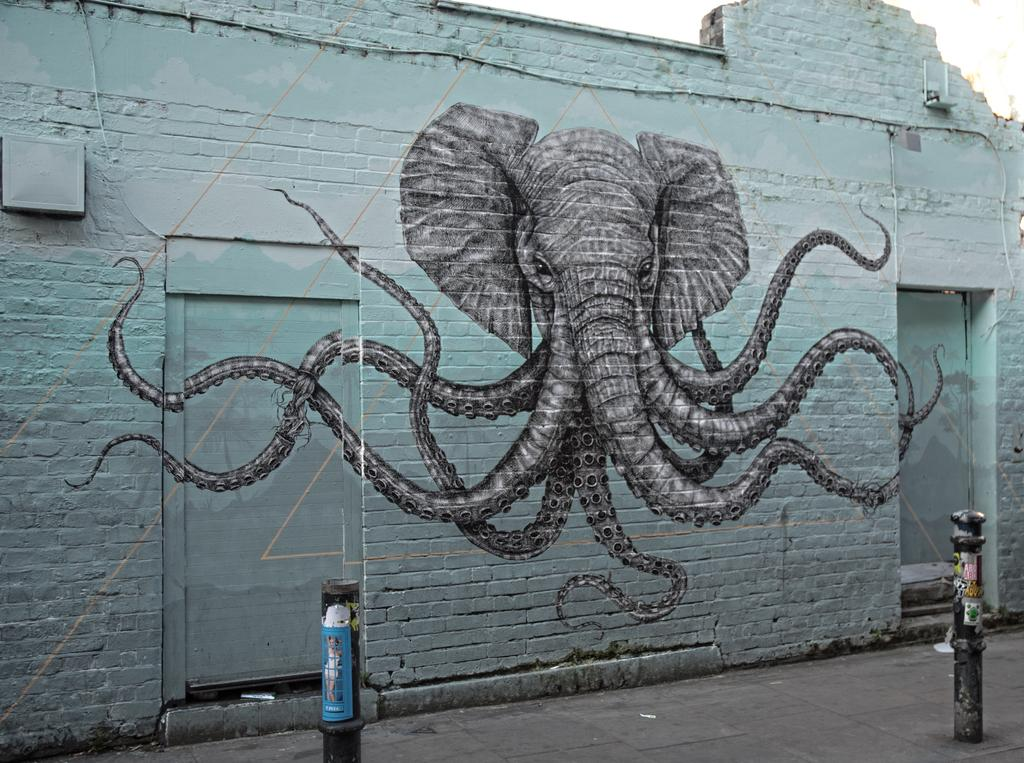What is depicted on the wall in the image? There is elephant graffiti on the wall in the image. Are there any other objects or structures in front of the wall? Yes, there are two poles in front of the wall. What type of breakfast is being served on the seat in the image? There is no seat or breakfast present in the image; it only features a wall with elephant graffiti and two poles. 